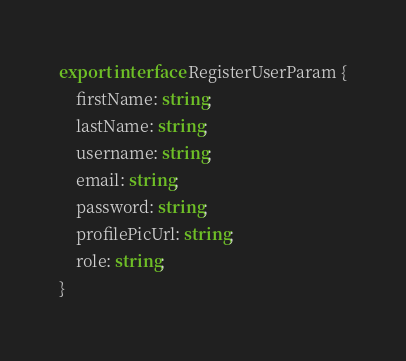Convert code to text. <code><loc_0><loc_0><loc_500><loc_500><_TypeScript_>export interface RegisterUserParam {
    firstName: string;
    lastName: string;
    username: string;
    email: string;
    password: string;
    profilePicUrl: string;
    role: string;    
}
</code> 